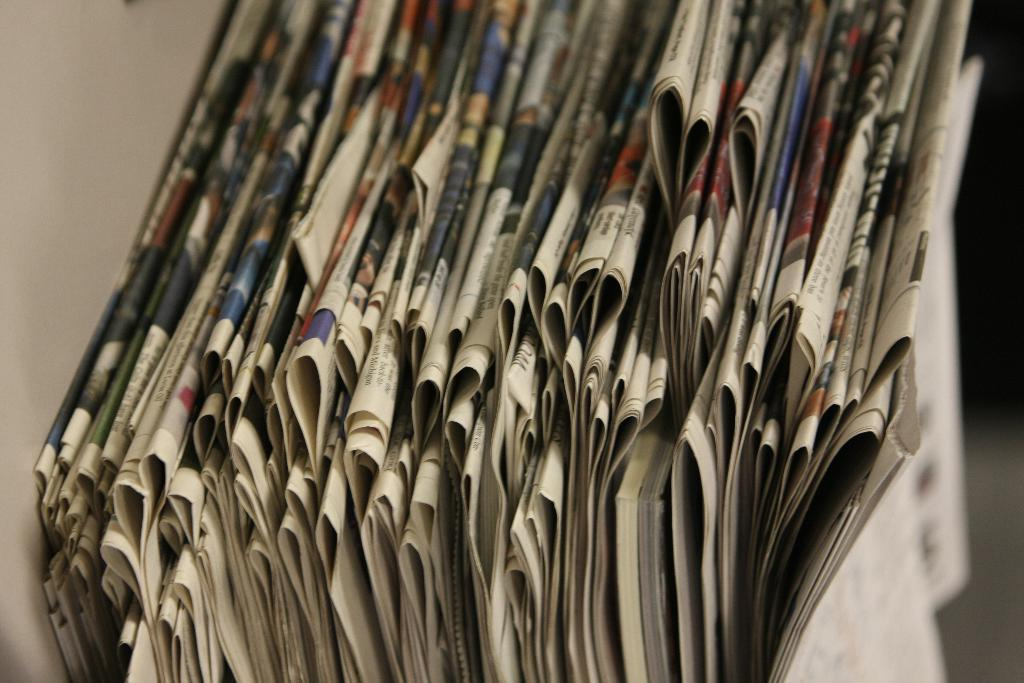What type of reading material is visible in the image? There are newspapers in the image. What can be seen on the left side of the image? There is a wall on the left side of the image. What might be the surface on the right side of the image? The right side of the image appears blurry and may depict a floor. What type of test can be seen being administered in the image? There is no test or testing scenario present in the image; it only features newspapers and a wall. 